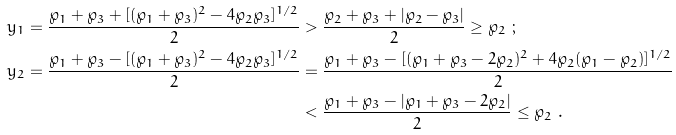<formula> <loc_0><loc_0><loc_500><loc_500>y _ { 1 } = \frac { \wp _ { 1 } + \wp _ { 3 } + [ ( \wp _ { 1 } + \wp _ { 3 } ) ^ { 2 } - 4 \wp _ { 2 } \wp _ { 3 } ] ^ { 1 / 2 } } { 2 } & > \frac { \wp _ { 2 } + \wp _ { 3 } + | \wp _ { 2 } - \wp _ { 3 } | } { 2 } \geq \wp _ { 2 } \ ; \\ y _ { 2 } = \frac { \wp _ { 1 } + \wp _ { 3 } - [ ( \wp _ { 1 } + \wp _ { 3 } ) ^ { 2 } - 4 \wp _ { 2 } \wp _ { 3 } ] ^ { 1 / 2 } } { 2 } & = \frac { \wp _ { 1 } + \wp _ { 3 } - [ ( \wp _ { 1 } + \wp _ { 3 } - 2 \wp _ { 2 } ) ^ { 2 } + 4 \wp _ { 2 } ( \wp _ { 1 } - \wp _ { 2 } ) ] ^ { 1 / 2 } } { 2 } \\ & < \frac { \wp _ { 1 } + \wp _ { 3 } - | \wp _ { 1 } + \wp _ { 3 } - 2 \wp _ { 2 } | } { 2 } \leq \wp _ { 2 } \ .</formula> 